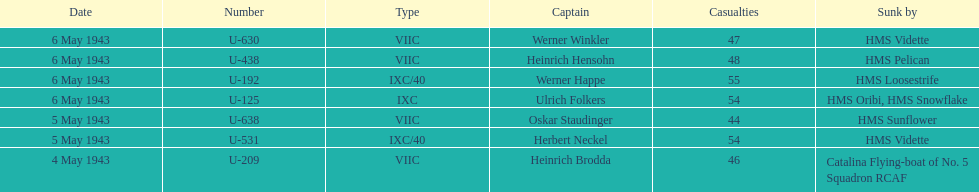What is the only vessel to sink multiple u-boats? HMS Vidette. 